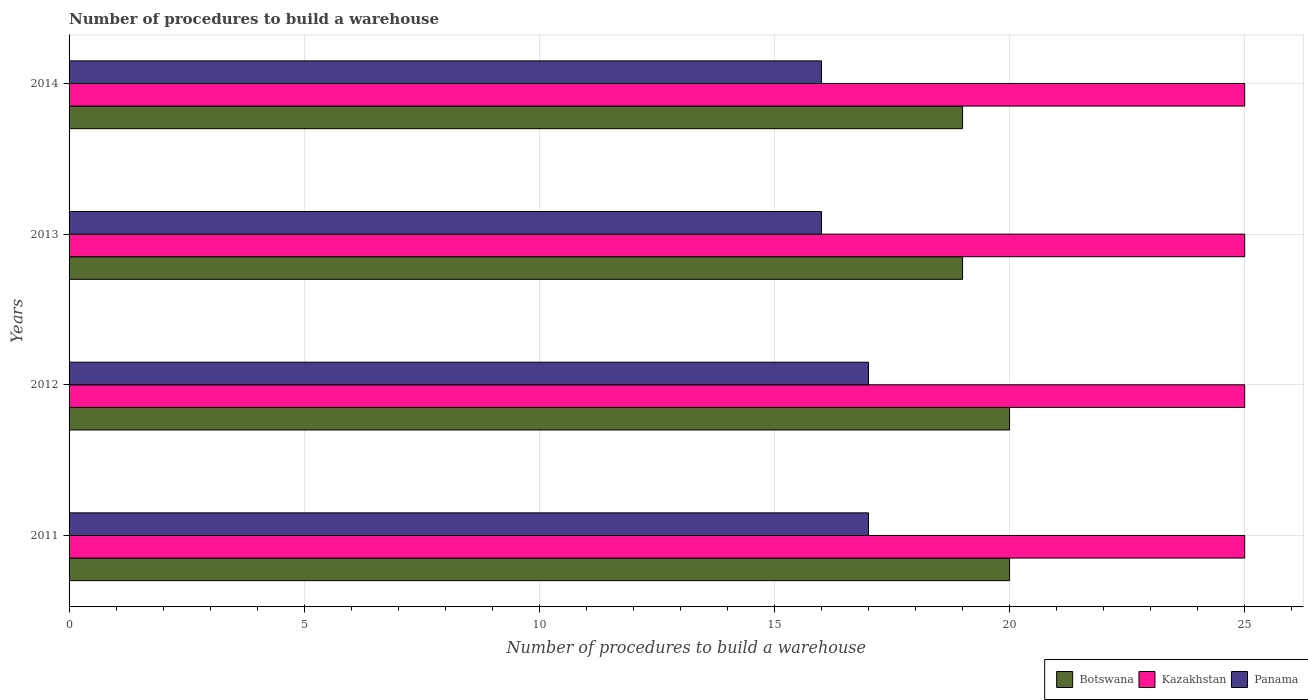Are the number of bars per tick equal to the number of legend labels?
Your answer should be compact. Yes. How many bars are there on the 2nd tick from the bottom?
Keep it short and to the point. 3. What is the label of the 3rd group of bars from the top?
Provide a short and direct response. 2012. In how many cases, is the number of bars for a given year not equal to the number of legend labels?
Ensure brevity in your answer.  0. What is the number of procedures to build a warehouse in in Kazakhstan in 2011?
Ensure brevity in your answer.  25. Across all years, what is the maximum number of procedures to build a warehouse in in Botswana?
Ensure brevity in your answer.  20. Across all years, what is the minimum number of procedures to build a warehouse in in Panama?
Your answer should be compact. 16. In which year was the number of procedures to build a warehouse in in Kazakhstan maximum?
Give a very brief answer. 2011. In which year was the number of procedures to build a warehouse in in Panama minimum?
Provide a short and direct response. 2013. What is the total number of procedures to build a warehouse in in Botswana in the graph?
Keep it short and to the point. 78. What is the difference between the number of procedures to build a warehouse in in Panama in 2011 and that in 2014?
Provide a succinct answer. 1. What is the difference between the number of procedures to build a warehouse in in Kazakhstan in 2014 and the number of procedures to build a warehouse in in Panama in 2013?
Your answer should be compact. 9. In the year 2011, what is the difference between the number of procedures to build a warehouse in in Kazakhstan and number of procedures to build a warehouse in in Panama?
Provide a succinct answer. 8. In how many years, is the number of procedures to build a warehouse in in Kazakhstan greater than 12 ?
Provide a succinct answer. 4. What is the ratio of the number of procedures to build a warehouse in in Botswana in 2011 to that in 2014?
Provide a short and direct response. 1.05. What is the difference between the highest and the lowest number of procedures to build a warehouse in in Kazakhstan?
Provide a succinct answer. 0. In how many years, is the number of procedures to build a warehouse in in Panama greater than the average number of procedures to build a warehouse in in Panama taken over all years?
Make the answer very short. 2. Is the sum of the number of procedures to build a warehouse in in Kazakhstan in 2011 and 2012 greater than the maximum number of procedures to build a warehouse in in Panama across all years?
Your response must be concise. Yes. What does the 2nd bar from the top in 2011 represents?
Your response must be concise. Kazakhstan. What does the 3rd bar from the bottom in 2013 represents?
Offer a terse response. Panama. How many bars are there?
Offer a very short reply. 12. What is the difference between two consecutive major ticks on the X-axis?
Your answer should be compact. 5. Does the graph contain any zero values?
Your answer should be compact. No. Where does the legend appear in the graph?
Keep it short and to the point. Bottom right. How many legend labels are there?
Offer a very short reply. 3. How are the legend labels stacked?
Your response must be concise. Horizontal. What is the title of the graph?
Offer a very short reply. Number of procedures to build a warehouse. What is the label or title of the X-axis?
Give a very brief answer. Number of procedures to build a warehouse. What is the label or title of the Y-axis?
Give a very brief answer. Years. What is the Number of procedures to build a warehouse of Botswana in 2012?
Keep it short and to the point. 20. What is the Number of procedures to build a warehouse of Panama in 2012?
Provide a succinct answer. 17. What is the Number of procedures to build a warehouse in Kazakhstan in 2013?
Make the answer very short. 25. What is the Number of procedures to build a warehouse in Panama in 2013?
Offer a very short reply. 16. What is the Number of procedures to build a warehouse of Kazakhstan in 2014?
Give a very brief answer. 25. Across all years, what is the maximum Number of procedures to build a warehouse in Kazakhstan?
Your answer should be compact. 25. Across all years, what is the maximum Number of procedures to build a warehouse of Panama?
Keep it short and to the point. 17. Across all years, what is the minimum Number of procedures to build a warehouse of Panama?
Ensure brevity in your answer.  16. What is the total Number of procedures to build a warehouse in Botswana in the graph?
Offer a terse response. 78. What is the total Number of procedures to build a warehouse of Kazakhstan in the graph?
Offer a very short reply. 100. What is the difference between the Number of procedures to build a warehouse in Botswana in 2011 and that in 2012?
Provide a short and direct response. 0. What is the difference between the Number of procedures to build a warehouse in Kazakhstan in 2011 and that in 2012?
Ensure brevity in your answer.  0. What is the difference between the Number of procedures to build a warehouse in Kazakhstan in 2011 and that in 2013?
Give a very brief answer. 0. What is the difference between the Number of procedures to build a warehouse of Kazakhstan in 2011 and that in 2014?
Offer a very short reply. 0. What is the difference between the Number of procedures to build a warehouse in Botswana in 2012 and that in 2013?
Offer a terse response. 1. What is the difference between the Number of procedures to build a warehouse in Panama in 2012 and that in 2013?
Provide a succinct answer. 1. What is the difference between the Number of procedures to build a warehouse of Kazakhstan in 2012 and that in 2014?
Offer a very short reply. 0. What is the difference between the Number of procedures to build a warehouse of Panama in 2012 and that in 2014?
Give a very brief answer. 1. What is the difference between the Number of procedures to build a warehouse of Botswana in 2011 and the Number of procedures to build a warehouse of Kazakhstan in 2012?
Offer a very short reply. -5. What is the difference between the Number of procedures to build a warehouse in Botswana in 2011 and the Number of procedures to build a warehouse in Panama in 2012?
Your answer should be very brief. 3. What is the difference between the Number of procedures to build a warehouse of Kazakhstan in 2011 and the Number of procedures to build a warehouse of Panama in 2012?
Keep it short and to the point. 8. What is the difference between the Number of procedures to build a warehouse of Botswana in 2011 and the Number of procedures to build a warehouse of Kazakhstan in 2013?
Ensure brevity in your answer.  -5. What is the difference between the Number of procedures to build a warehouse in Kazakhstan in 2011 and the Number of procedures to build a warehouse in Panama in 2013?
Keep it short and to the point. 9. What is the difference between the Number of procedures to build a warehouse in Botswana in 2011 and the Number of procedures to build a warehouse in Panama in 2014?
Provide a short and direct response. 4. What is the difference between the Number of procedures to build a warehouse in Botswana in 2012 and the Number of procedures to build a warehouse in Kazakhstan in 2013?
Your answer should be compact. -5. What is the difference between the Number of procedures to build a warehouse in Kazakhstan in 2012 and the Number of procedures to build a warehouse in Panama in 2013?
Offer a very short reply. 9. What is the difference between the Number of procedures to build a warehouse in Botswana in 2012 and the Number of procedures to build a warehouse in Kazakhstan in 2014?
Offer a very short reply. -5. What is the difference between the Number of procedures to build a warehouse in Botswana in 2013 and the Number of procedures to build a warehouse in Kazakhstan in 2014?
Ensure brevity in your answer.  -6. What is the difference between the Number of procedures to build a warehouse of Botswana in 2013 and the Number of procedures to build a warehouse of Panama in 2014?
Your response must be concise. 3. What is the average Number of procedures to build a warehouse of Botswana per year?
Make the answer very short. 19.5. What is the average Number of procedures to build a warehouse of Kazakhstan per year?
Your response must be concise. 25. What is the average Number of procedures to build a warehouse of Panama per year?
Provide a short and direct response. 16.5. In the year 2011, what is the difference between the Number of procedures to build a warehouse in Kazakhstan and Number of procedures to build a warehouse in Panama?
Your answer should be compact. 8. In the year 2012, what is the difference between the Number of procedures to build a warehouse of Botswana and Number of procedures to build a warehouse of Kazakhstan?
Offer a very short reply. -5. In the year 2012, what is the difference between the Number of procedures to build a warehouse in Botswana and Number of procedures to build a warehouse in Panama?
Provide a succinct answer. 3. In the year 2014, what is the difference between the Number of procedures to build a warehouse of Botswana and Number of procedures to build a warehouse of Panama?
Offer a very short reply. 3. What is the ratio of the Number of procedures to build a warehouse in Botswana in 2011 to that in 2012?
Provide a succinct answer. 1. What is the ratio of the Number of procedures to build a warehouse in Panama in 2011 to that in 2012?
Your response must be concise. 1. What is the ratio of the Number of procedures to build a warehouse of Botswana in 2011 to that in 2013?
Give a very brief answer. 1.05. What is the ratio of the Number of procedures to build a warehouse of Kazakhstan in 2011 to that in 2013?
Provide a short and direct response. 1. What is the ratio of the Number of procedures to build a warehouse in Panama in 2011 to that in 2013?
Your answer should be compact. 1.06. What is the ratio of the Number of procedures to build a warehouse of Botswana in 2011 to that in 2014?
Provide a succinct answer. 1.05. What is the ratio of the Number of procedures to build a warehouse in Botswana in 2012 to that in 2013?
Make the answer very short. 1.05. What is the ratio of the Number of procedures to build a warehouse in Botswana in 2012 to that in 2014?
Offer a terse response. 1.05. What is the ratio of the Number of procedures to build a warehouse of Panama in 2012 to that in 2014?
Offer a terse response. 1.06. What is the ratio of the Number of procedures to build a warehouse in Botswana in 2013 to that in 2014?
Your answer should be compact. 1. What is the difference between the highest and the second highest Number of procedures to build a warehouse in Botswana?
Make the answer very short. 0. What is the difference between the highest and the second highest Number of procedures to build a warehouse of Kazakhstan?
Make the answer very short. 0. What is the difference between the highest and the second highest Number of procedures to build a warehouse in Panama?
Your response must be concise. 0. What is the difference between the highest and the lowest Number of procedures to build a warehouse of Kazakhstan?
Your response must be concise. 0. 